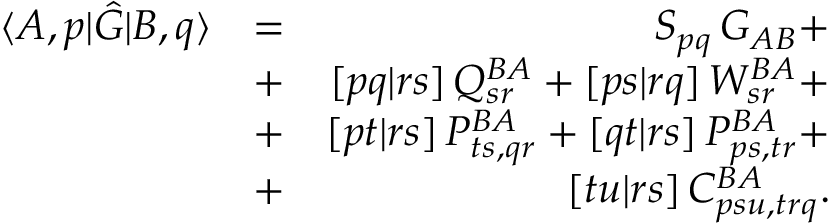<formula> <loc_0><loc_0><loc_500><loc_500>\begin{array} { r l r } { \langle A , p | \hat { G } | B , q \rangle } & { = } & { S _ { p q } \, G _ { A B } + } \\ & { + } & { [ p q | r s ] \, Q _ { s r } ^ { B A } + [ p s | r q ] \, W _ { s r } ^ { B A } + } \\ & { + } & { [ p t | r s ] \, P _ { t s , q r } ^ { B A } + [ q t | r s ] \, P _ { p s , t r } ^ { B A } + } \\ & { + } & { [ t u | r s ] \, C _ { p s u , t r q } ^ { B A } . } \end{array}</formula> 